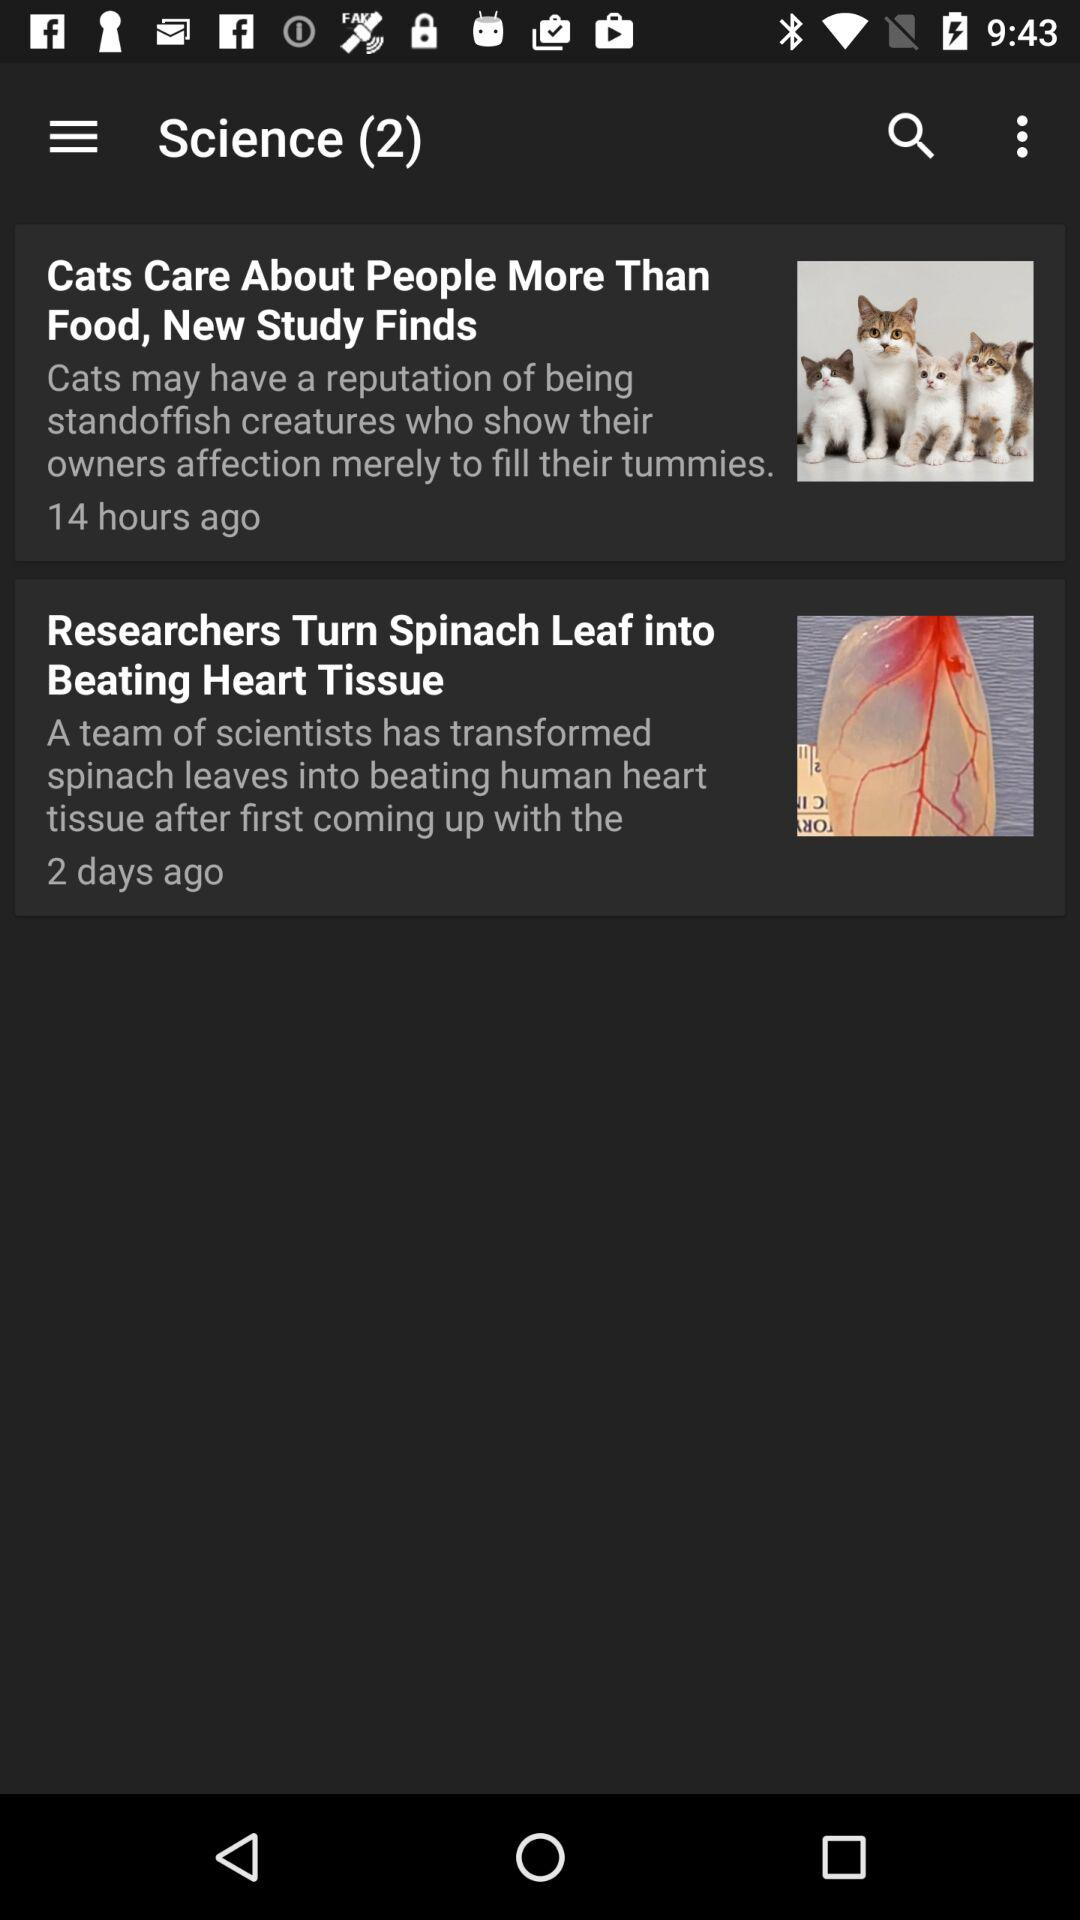How many hours ago was the article about cats published?
Answer the question using a single word or phrase. 14 